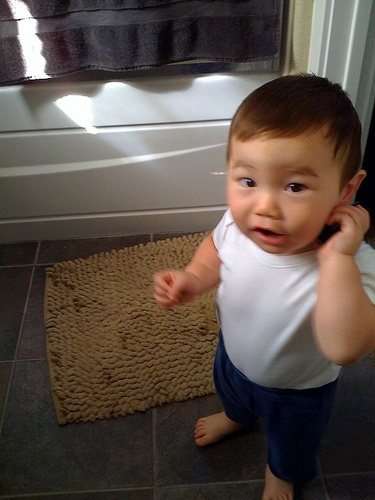Describe the objects in this image and their specific colors. I can see people in black, gray, darkgray, and lightgray tones and cell phone in black, maroon, and brown tones in this image. 